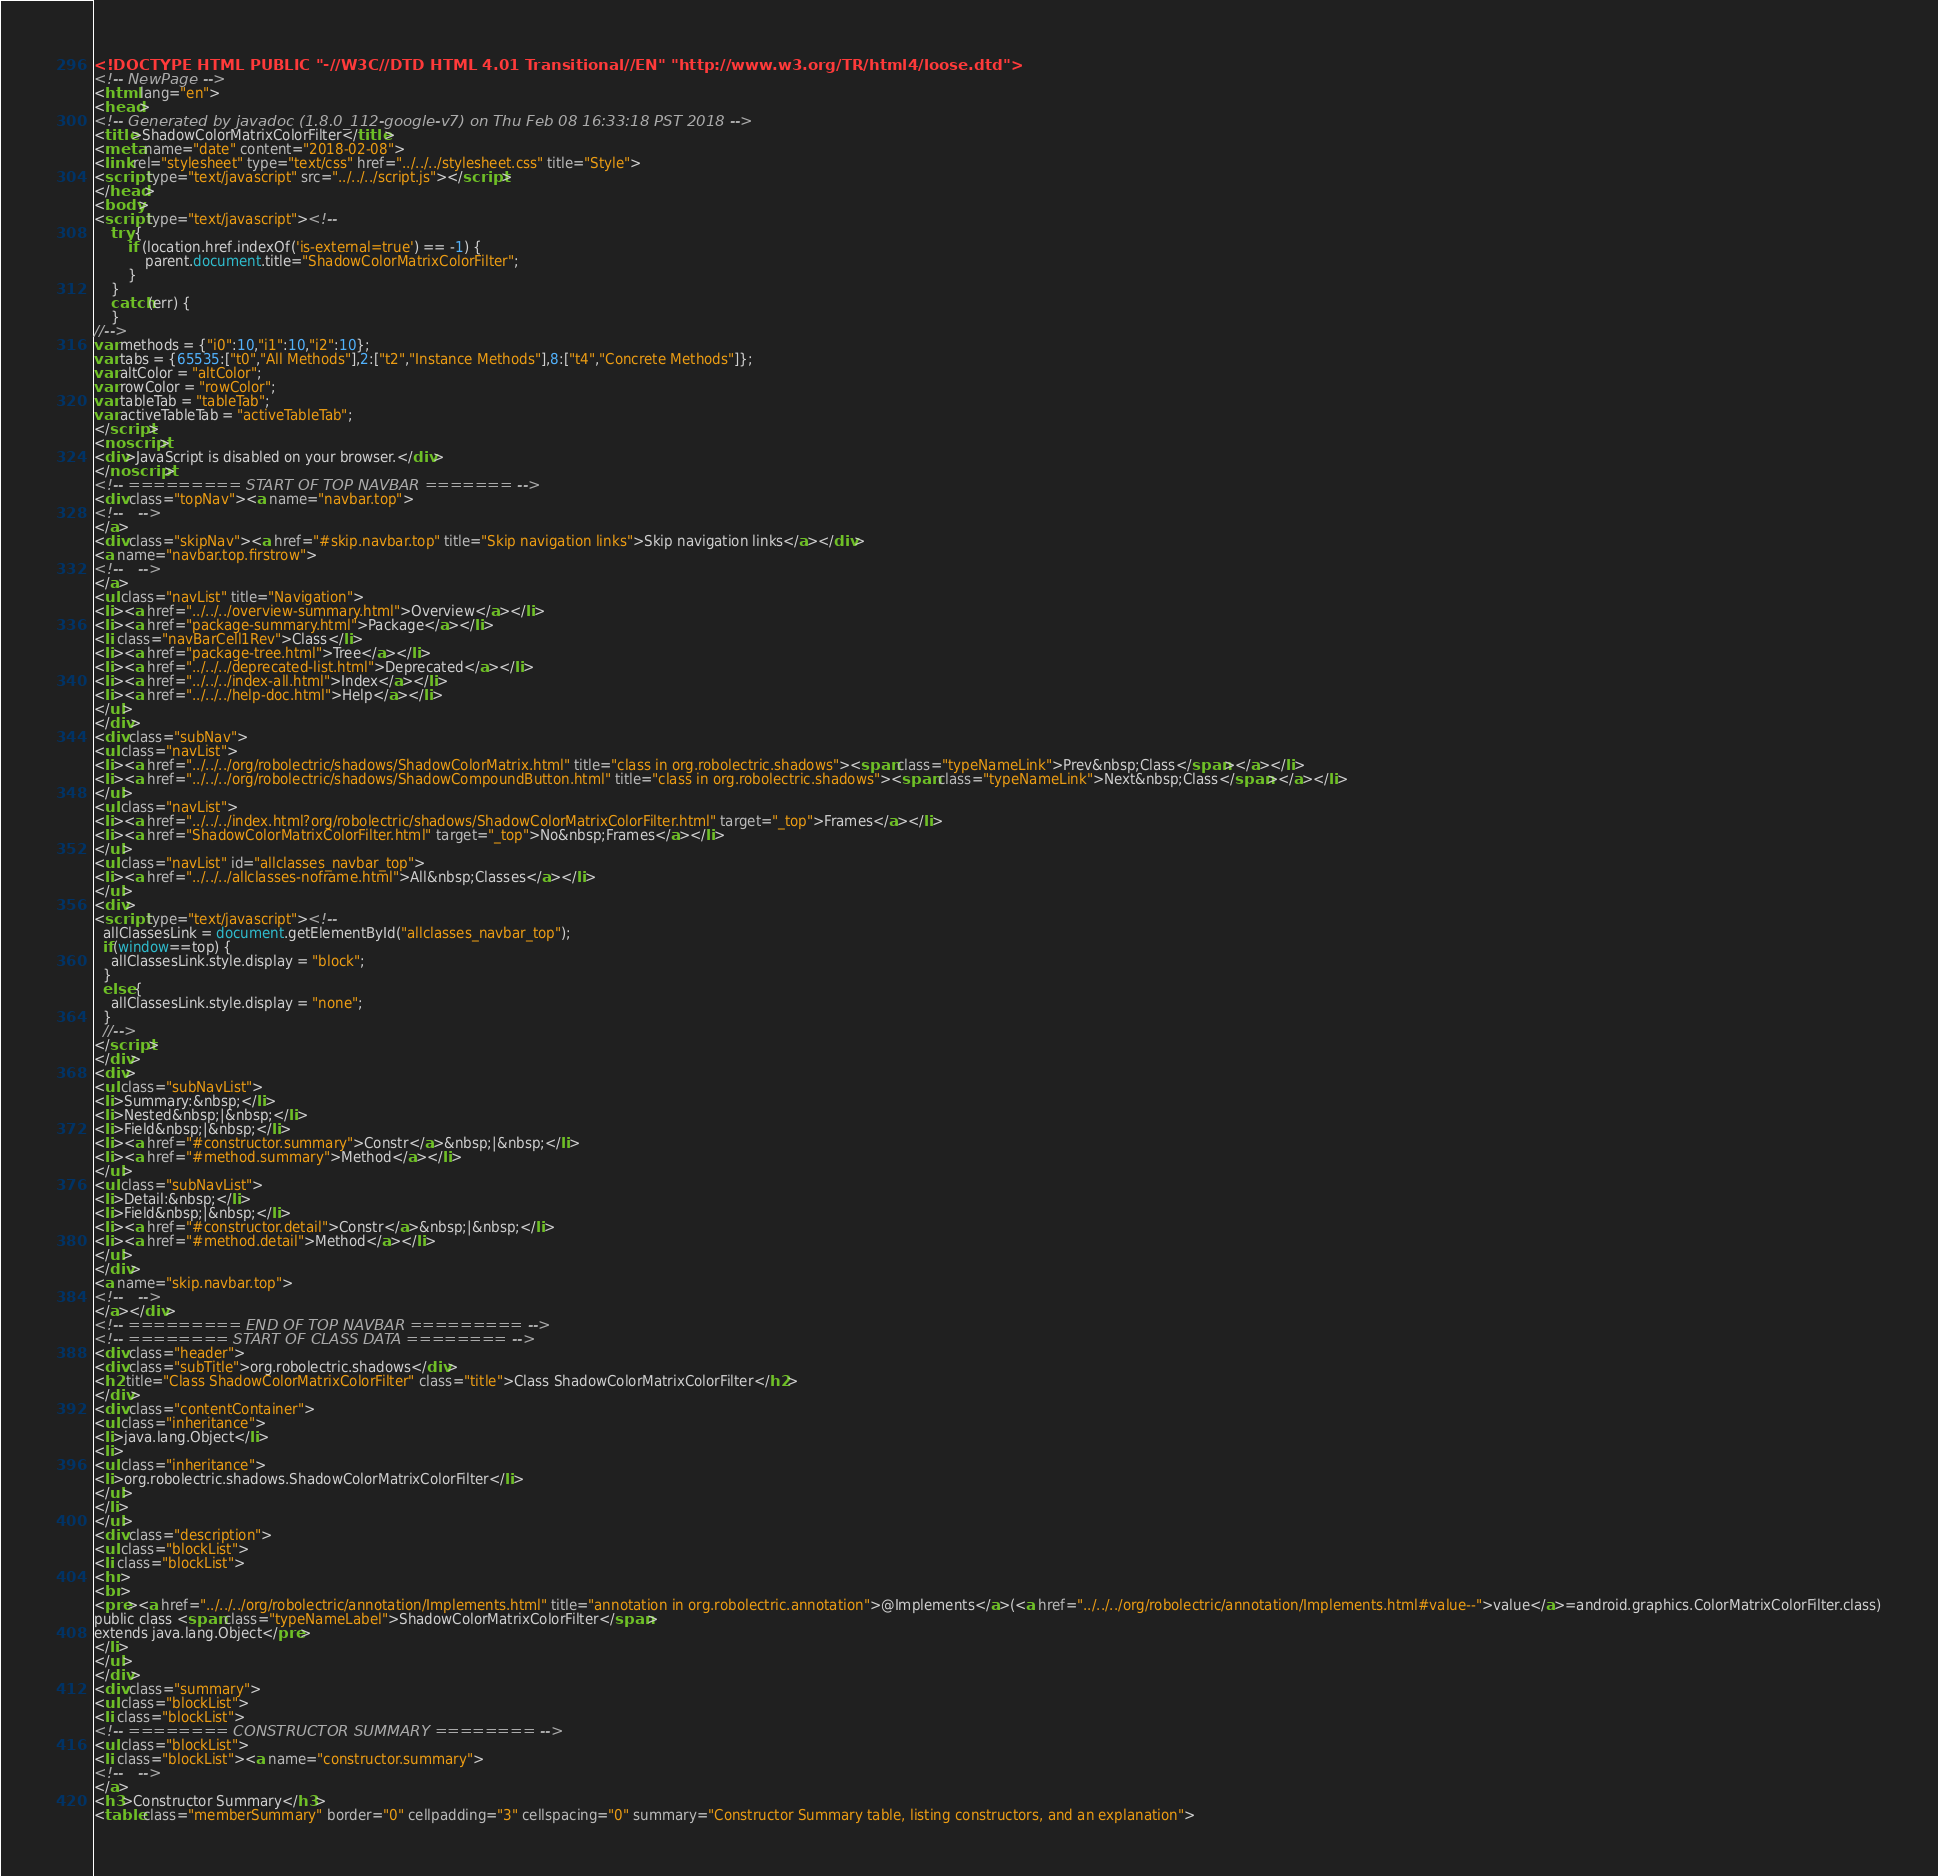<code> <loc_0><loc_0><loc_500><loc_500><_HTML_><!DOCTYPE HTML PUBLIC "-//W3C//DTD HTML 4.01 Transitional//EN" "http://www.w3.org/TR/html4/loose.dtd">
<!-- NewPage -->
<html lang="en">
<head>
<!-- Generated by javadoc (1.8.0_112-google-v7) on Thu Feb 08 16:33:18 PST 2018 -->
<title>ShadowColorMatrixColorFilter</title>
<meta name="date" content="2018-02-08">
<link rel="stylesheet" type="text/css" href="../../../stylesheet.css" title="Style">
<script type="text/javascript" src="../../../script.js"></script>
</head>
<body>
<script type="text/javascript"><!--
    try {
        if (location.href.indexOf('is-external=true') == -1) {
            parent.document.title="ShadowColorMatrixColorFilter";
        }
    }
    catch(err) {
    }
//-->
var methods = {"i0":10,"i1":10,"i2":10};
var tabs = {65535:["t0","All Methods"],2:["t2","Instance Methods"],8:["t4","Concrete Methods"]};
var altColor = "altColor";
var rowColor = "rowColor";
var tableTab = "tableTab";
var activeTableTab = "activeTableTab";
</script>
<noscript>
<div>JavaScript is disabled on your browser.</div>
</noscript>
<!-- ========= START OF TOP NAVBAR ======= -->
<div class="topNav"><a name="navbar.top">
<!--   -->
</a>
<div class="skipNav"><a href="#skip.navbar.top" title="Skip navigation links">Skip navigation links</a></div>
<a name="navbar.top.firstrow">
<!--   -->
</a>
<ul class="navList" title="Navigation">
<li><a href="../../../overview-summary.html">Overview</a></li>
<li><a href="package-summary.html">Package</a></li>
<li class="navBarCell1Rev">Class</li>
<li><a href="package-tree.html">Tree</a></li>
<li><a href="../../../deprecated-list.html">Deprecated</a></li>
<li><a href="../../../index-all.html">Index</a></li>
<li><a href="../../../help-doc.html">Help</a></li>
</ul>
</div>
<div class="subNav">
<ul class="navList">
<li><a href="../../../org/robolectric/shadows/ShadowColorMatrix.html" title="class in org.robolectric.shadows"><span class="typeNameLink">Prev&nbsp;Class</span></a></li>
<li><a href="../../../org/robolectric/shadows/ShadowCompoundButton.html" title="class in org.robolectric.shadows"><span class="typeNameLink">Next&nbsp;Class</span></a></li>
</ul>
<ul class="navList">
<li><a href="../../../index.html?org/robolectric/shadows/ShadowColorMatrixColorFilter.html" target="_top">Frames</a></li>
<li><a href="ShadowColorMatrixColorFilter.html" target="_top">No&nbsp;Frames</a></li>
</ul>
<ul class="navList" id="allclasses_navbar_top">
<li><a href="../../../allclasses-noframe.html">All&nbsp;Classes</a></li>
</ul>
<div>
<script type="text/javascript"><!--
  allClassesLink = document.getElementById("allclasses_navbar_top");
  if(window==top) {
    allClassesLink.style.display = "block";
  }
  else {
    allClassesLink.style.display = "none";
  }
  //-->
</script>
</div>
<div>
<ul class="subNavList">
<li>Summary:&nbsp;</li>
<li>Nested&nbsp;|&nbsp;</li>
<li>Field&nbsp;|&nbsp;</li>
<li><a href="#constructor.summary">Constr</a>&nbsp;|&nbsp;</li>
<li><a href="#method.summary">Method</a></li>
</ul>
<ul class="subNavList">
<li>Detail:&nbsp;</li>
<li>Field&nbsp;|&nbsp;</li>
<li><a href="#constructor.detail">Constr</a>&nbsp;|&nbsp;</li>
<li><a href="#method.detail">Method</a></li>
</ul>
</div>
<a name="skip.navbar.top">
<!--   -->
</a></div>
<!-- ========= END OF TOP NAVBAR ========= -->
<!-- ======== START OF CLASS DATA ======== -->
<div class="header">
<div class="subTitle">org.robolectric.shadows</div>
<h2 title="Class ShadowColorMatrixColorFilter" class="title">Class ShadowColorMatrixColorFilter</h2>
</div>
<div class="contentContainer">
<ul class="inheritance">
<li>java.lang.Object</li>
<li>
<ul class="inheritance">
<li>org.robolectric.shadows.ShadowColorMatrixColorFilter</li>
</ul>
</li>
</ul>
<div class="description">
<ul class="blockList">
<li class="blockList">
<hr>
<br>
<pre><a href="../../../org/robolectric/annotation/Implements.html" title="annotation in org.robolectric.annotation">@Implements</a>(<a href="../../../org/robolectric/annotation/Implements.html#value--">value</a>=android.graphics.ColorMatrixColorFilter.class)
public class <span class="typeNameLabel">ShadowColorMatrixColorFilter</span>
extends java.lang.Object</pre>
</li>
</ul>
</div>
<div class="summary">
<ul class="blockList">
<li class="blockList">
<!-- ======== CONSTRUCTOR SUMMARY ======== -->
<ul class="blockList">
<li class="blockList"><a name="constructor.summary">
<!--   -->
</a>
<h3>Constructor Summary</h3>
<table class="memberSummary" border="0" cellpadding="3" cellspacing="0" summary="Constructor Summary table, listing constructors, and an explanation"></code> 